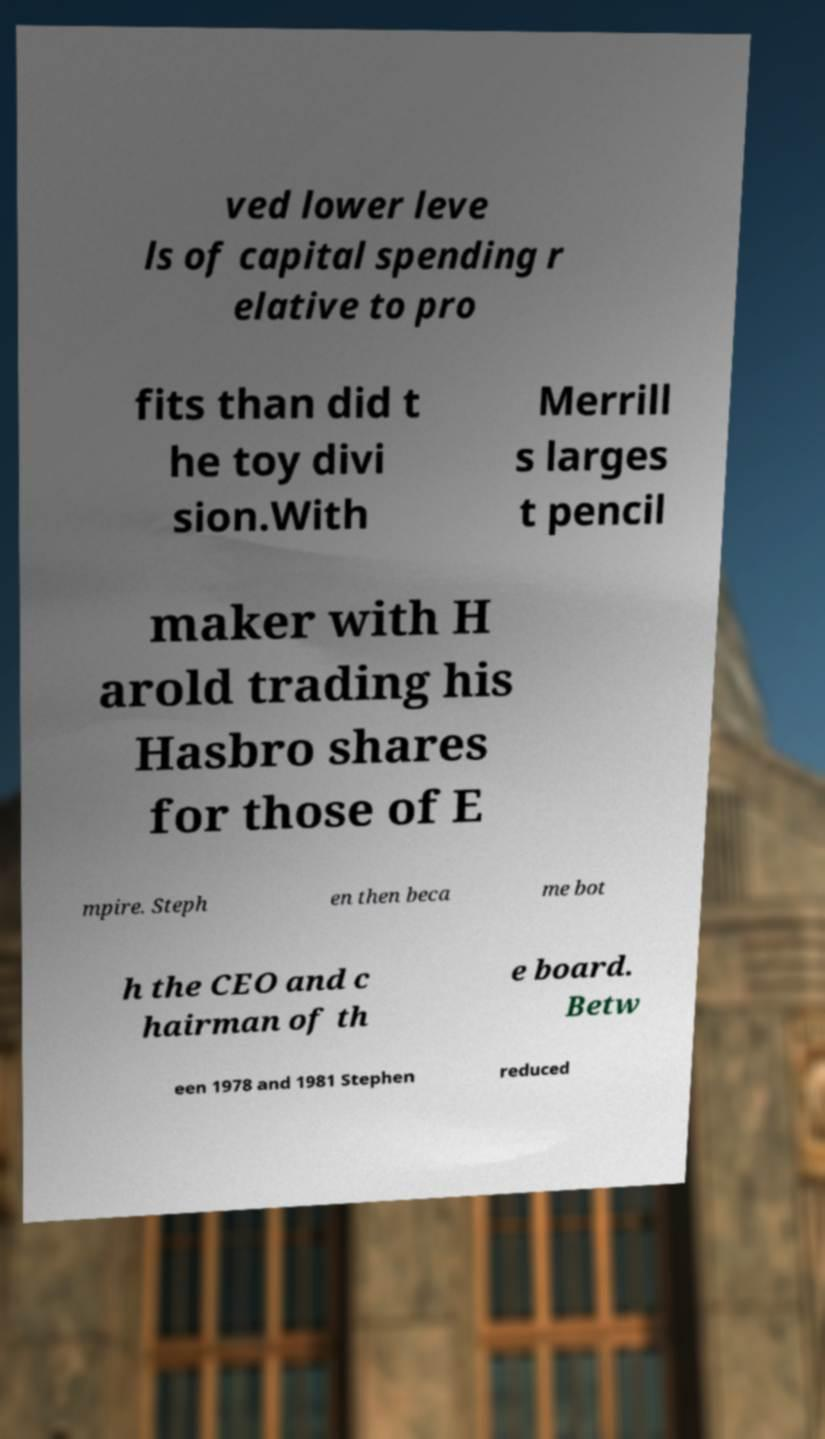Please read and relay the text visible in this image. What does it say? ved lower leve ls of capital spending r elative to pro fits than did t he toy divi sion.With Merrill s larges t pencil maker with H arold trading his Hasbro shares for those of E mpire. Steph en then beca me bot h the CEO and c hairman of th e board. Betw een 1978 and 1981 Stephen reduced 